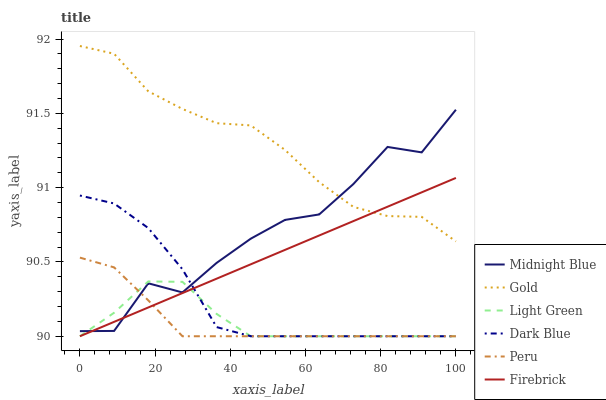Does Peru have the minimum area under the curve?
Answer yes or no. Yes. Does Gold have the maximum area under the curve?
Answer yes or no. Yes. Does Firebrick have the minimum area under the curve?
Answer yes or no. No. Does Firebrick have the maximum area under the curve?
Answer yes or no. No. Is Firebrick the smoothest?
Answer yes or no. Yes. Is Midnight Blue the roughest?
Answer yes or no. Yes. Is Gold the smoothest?
Answer yes or no. No. Is Gold the roughest?
Answer yes or no. No. Does Light Green have the lowest value?
Answer yes or no. Yes. Does Gold have the lowest value?
Answer yes or no. No. Does Gold have the highest value?
Answer yes or no. Yes. Does Firebrick have the highest value?
Answer yes or no. No. Is Light Green less than Gold?
Answer yes or no. Yes. Is Gold greater than Peru?
Answer yes or no. Yes. Does Midnight Blue intersect Light Green?
Answer yes or no. Yes. Is Midnight Blue less than Light Green?
Answer yes or no. No. Is Midnight Blue greater than Light Green?
Answer yes or no. No. Does Light Green intersect Gold?
Answer yes or no. No. 